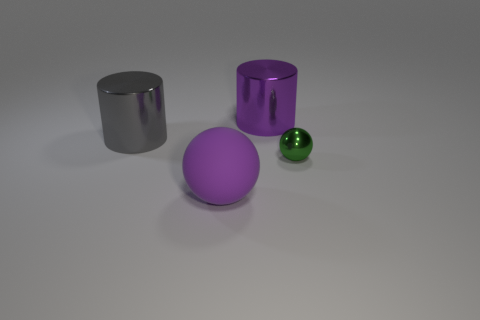Add 2 big gray metallic things. How many objects exist? 6 Subtract all purple cylinders. How many cylinders are left? 1 Subtract 1 balls. How many balls are left? 1 Subtract all yellow cylinders. Subtract all green spheres. How many cylinders are left? 2 Add 4 large gray metal cylinders. How many large gray metal cylinders are left? 5 Add 1 big gray matte cylinders. How many big gray matte cylinders exist? 1 Subtract 0 green blocks. How many objects are left? 4 Subtract all brown cylinders. How many purple spheres are left? 1 Subtract all purple things. Subtract all big brown cylinders. How many objects are left? 2 